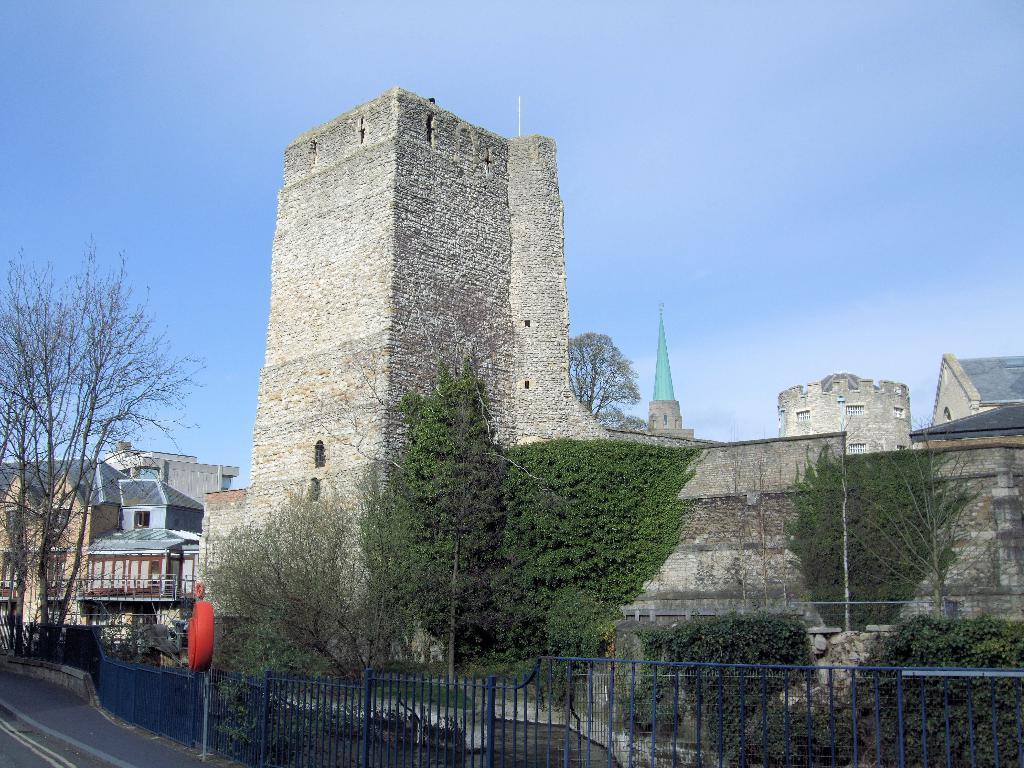Describe this image in one or two sentences. In this picture I can see buildings, trees and I can see metal fence and looks like a board to the pole on the sidewalk and I can see blue sky. 